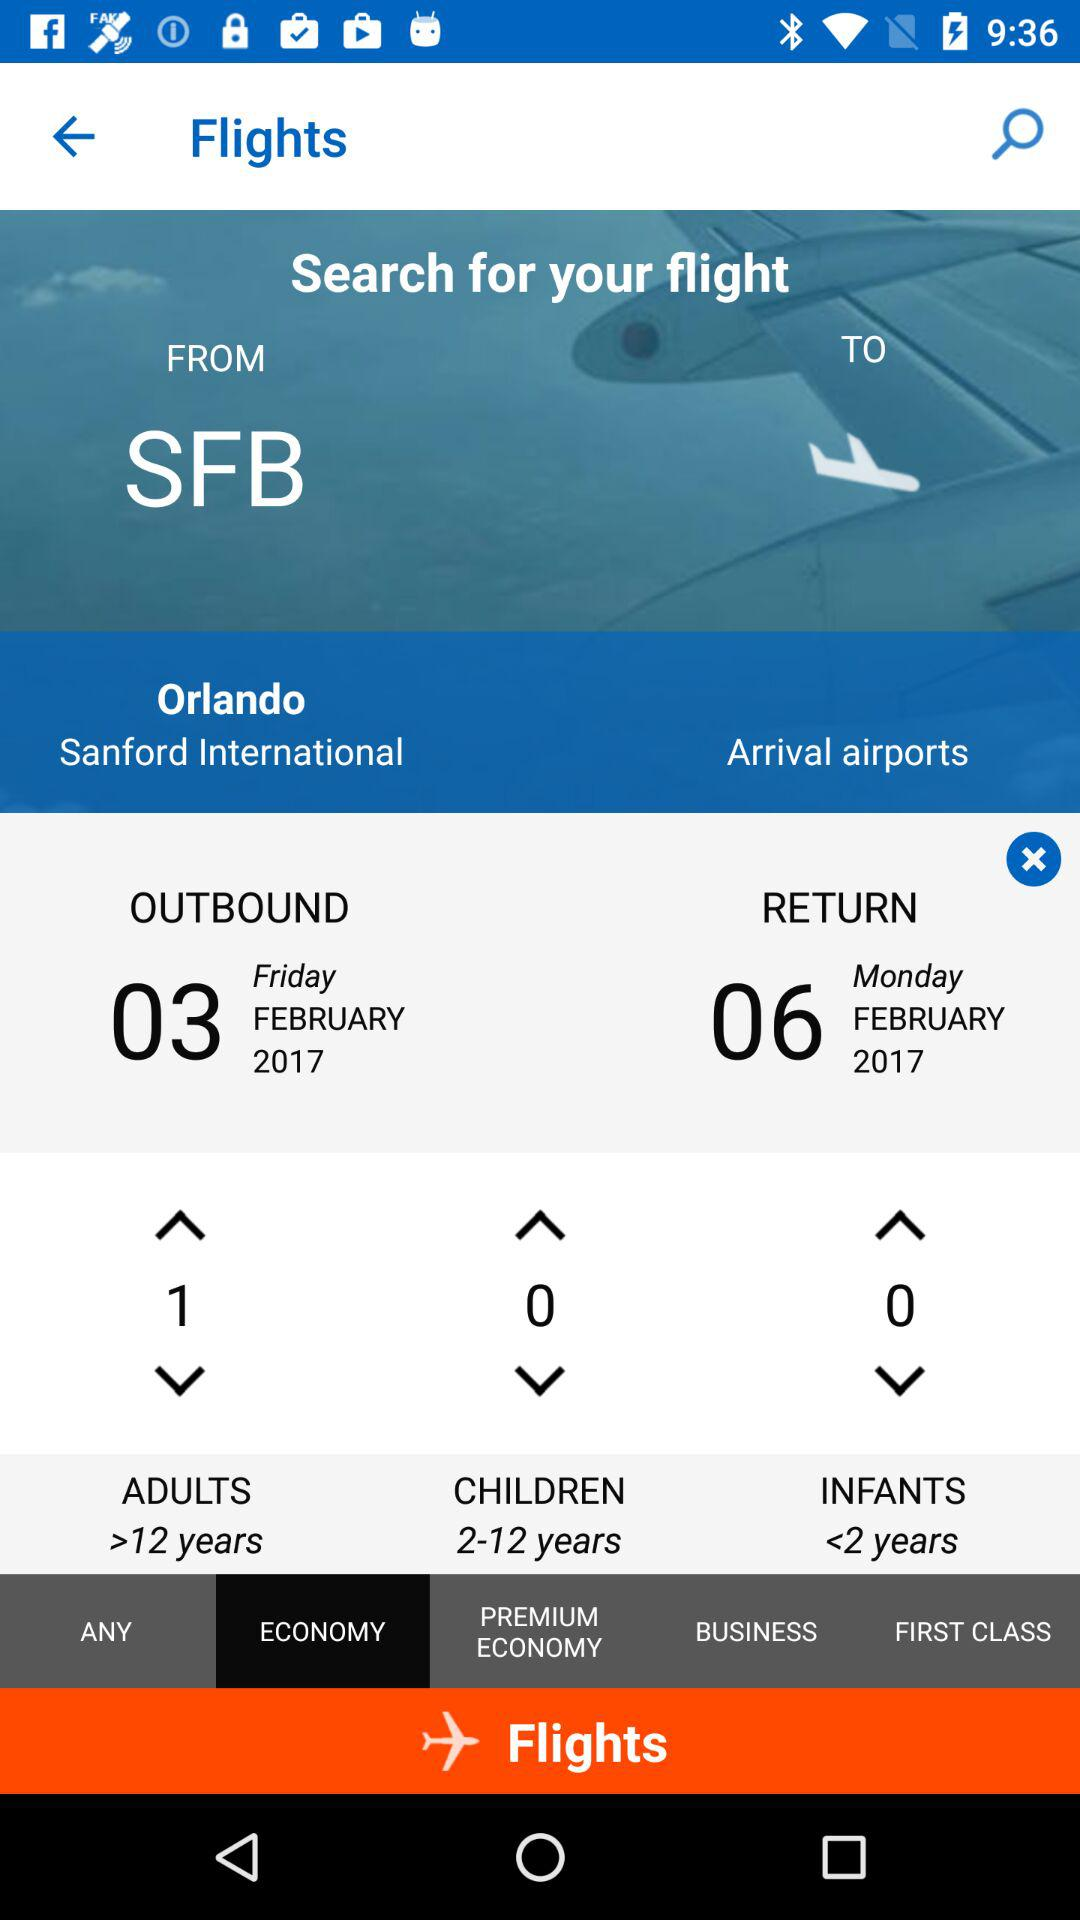What is the age limit for children? The age limit is 2–12 years. 